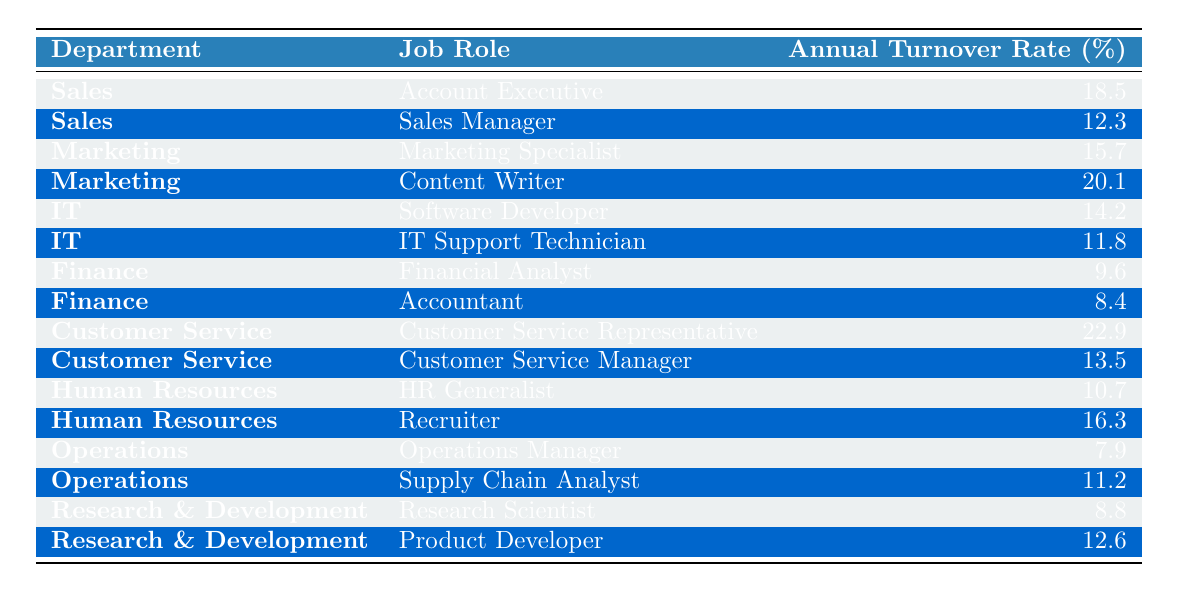What is the annual turnover rate for the Customer Service Representative role? From the table, the turnover rate for the Customer Service Representative role is directly specified as 22.9%.
Answer: 22.9% Which department has the highest annual turnover rate? By examining each department's highest turnover rates, the Customer Service department has the highest turnover at 22.9%.
Answer: Customer Service What is the turnover rate for the Accountant role? The table indicates that the turnover rate for the Accountant role is 8.4%.
Answer: 8.4% Which two job roles in Marketing have turnover rates above 15%? The two roles in Marketing with turnover rates above 15% are Content Writer (20.1%) and Marketing Specialist (15.7%).
Answer: Content Writer and Marketing Specialist What is the average annual turnover rate for the IT department? The turnover rates for IT roles are 14.2% (Software Developer) and 11.8% (IT Support Technician). The average is (14.2 + 11.8) / 2 = 13%.
Answer: 13% Is the annual turnover rate for HR Generalist higher than that for Financial Analyst? The table shows that the HR Generalist has a turnover rate of 10.7%, while the Financial Analyst has a rate of 9.6%, indicating that the HR Generalist's rate is higher.
Answer: Yes How many job roles have an annual turnover rate of above 15%? Reviewing the table, there are six roles with turnover rates above 15%: Account Executive (18.5%), Marketing Specialist (15.7%), Content Writer (20.1%), Customer Service Representative (22.9%), Recruiter (16.3%), and Operations Manager (7.9% does not count).
Answer: 5 Which role in the Operations department has the highest turnover rate? In the Operations department, the turnover rates are 7.9% (Operations Manager) and 11.2% (Supply Chain Analyst). The Supply Chain Analyst has a higher turnover rate of 11.2%.
Answer: Supply Chain Analyst What is the difference in turnover rates between the Sales Manager and Account Executive? The turnover rate for the Sales Manager is 12.3%, and for the Account Executive, it is 18.5%. The difference is 18.5% - 12.3% = 6.2%.
Answer: 6.2% Which role has the lowest turnover rate overall? The table shows that the Accountant has the lowest turnover rate at 8.4%.
Answer: Accountant 